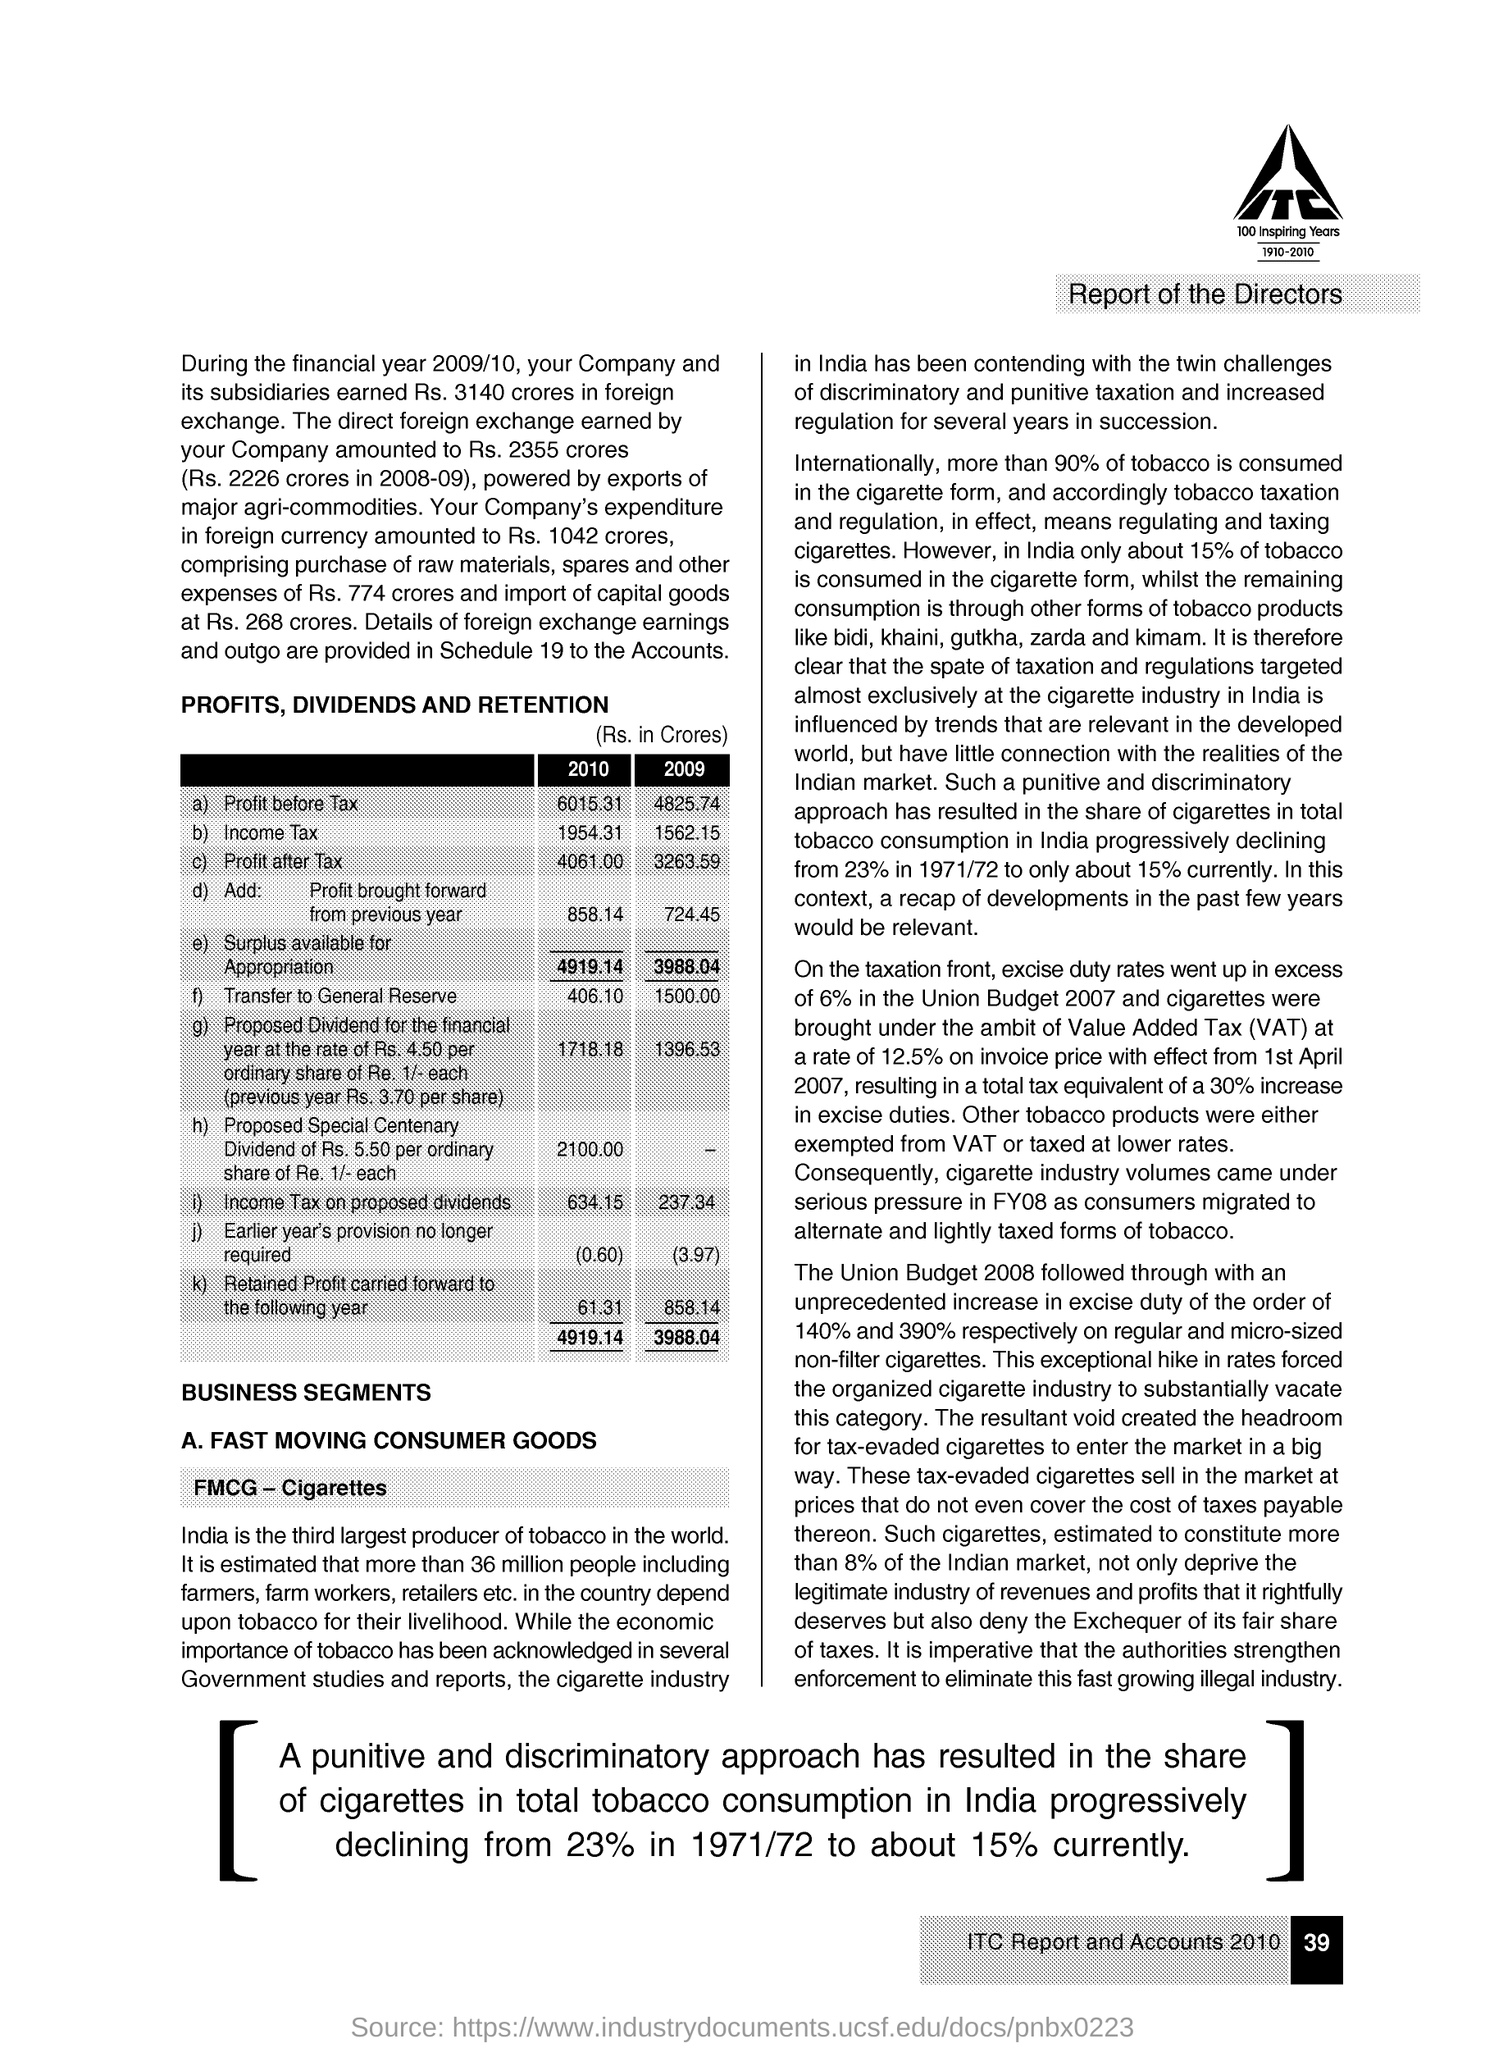Point out several critical features in this image. The surplus available for appropriation for the year 2009 is 3,988.04. The table named "PROFITS, DIVIDENDS AND RETENTION" is capitalized. The bold letters within the company logo read 'ITC'. According to international statistics, more than 90% of the tobacco consumed worldwide is in the form of cigarettes. The surplus available for appropriation for the year 2010 was 4,919.14. 